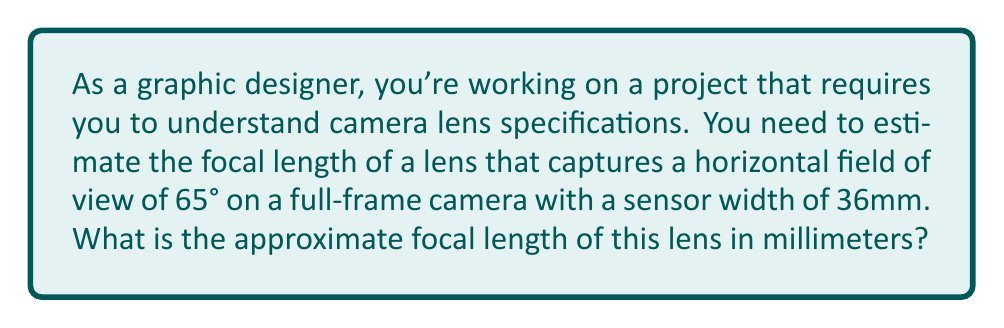Help me with this question. To solve this problem, we'll use the relationship between focal length, sensor size, and field of view. The formula we'll use is:

$$ \text{focal length} = \frac{\text{sensor width}}{2 \tan(\frac{\text{field of view}}{2})} $$

Let's break down the solution step by step:

1. We know the horizontal field of view is 65° and the sensor width is 36mm.

2. Convert the field of view to radians:
   $\frac{65°}{2} = 32.5°$
   $32.5° \times \frac{\pi}{180°} \approx 0.5672$ radians

3. Calculate $\tan(0.5672)$:
   $\tan(0.5672) \approx 0.6228$

4. Apply the formula:
   $$ \text{focal length} = \frac{36}{2 \times 0.6228} $$

5. Solve:
   $$ \text{focal length} \approx \frac{36}{1.2456} \approx 28.90 \text{ mm} $$

6. Round to the nearest standard focal length:
   The closest standard focal length is 28mm.

[asy]
import geometry;

// Define points
pair A = (0,0);
pair B = (100,0);
pair C = (50,86.6);

// Draw triangle
draw(A--B--C--A);

// Draw angle
draw(arc(C,20,270,335), Arrow);

// Labels
label("Sensor", (50,-10));
label("32.5°", (70,30));
label("Focal Length", (25,43), E);

// Focal length line
draw((50,0)--(50,86.6), dashed);
[/asy]

The diagram illustrates the relationship between the sensor width, field of view angle, and focal length in a simplified 2D representation.
Answer: The approximate focal length of the lens is 28mm. 